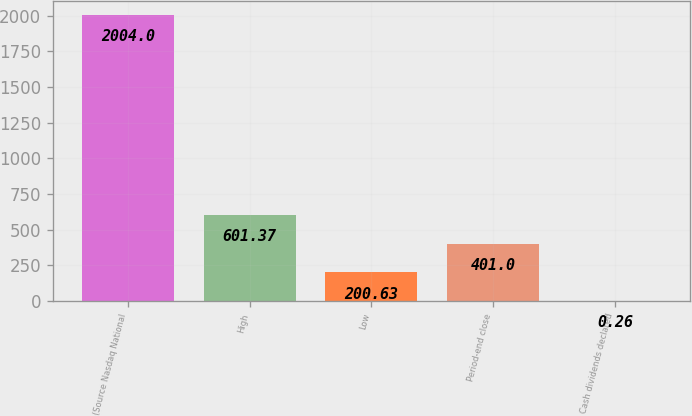Convert chart. <chart><loc_0><loc_0><loc_500><loc_500><bar_chart><fcel>(Source Nasdaq National<fcel>High<fcel>Low<fcel>Period-end close<fcel>Cash dividends declared<nl><fcel>2004<fcel>601.37<fcel>200.63<fcel>401<fcel>0.26<nl></chart> 